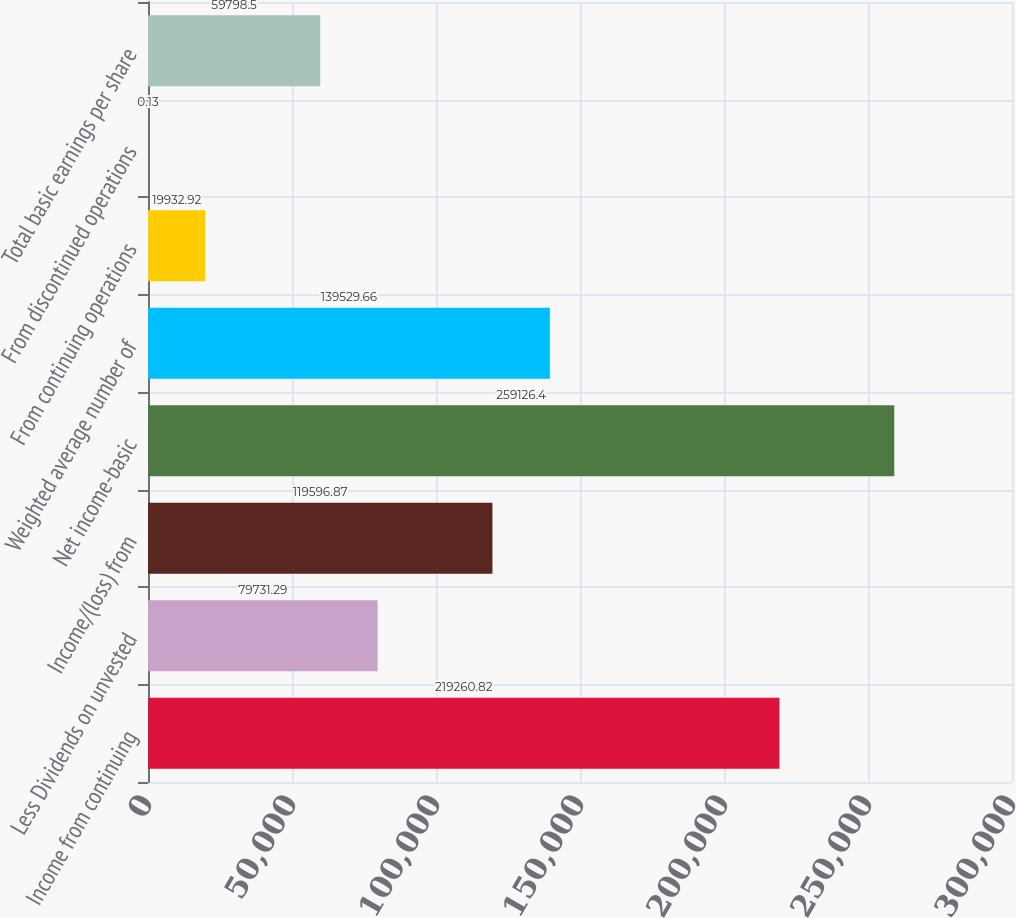<chart> <loc_0><loc_0><loc_500><loc_500><bar_chart><fcel>Income from continuing<fcel>Less Dividends on unvested<fcel>Income/(loss) from<fcel>Net income-basic<fcel>Weighted average number of<fcel>From continuing operations<fcel>From discontinued operations<fcel>Total basic earnings per share<nl><fcel>219261<fcel>79731.3<fcel>119597<fcel>259126<fcel>139530<fcel>19932.9<fcel>0.13<fcel>59798.5<nl></chart> 